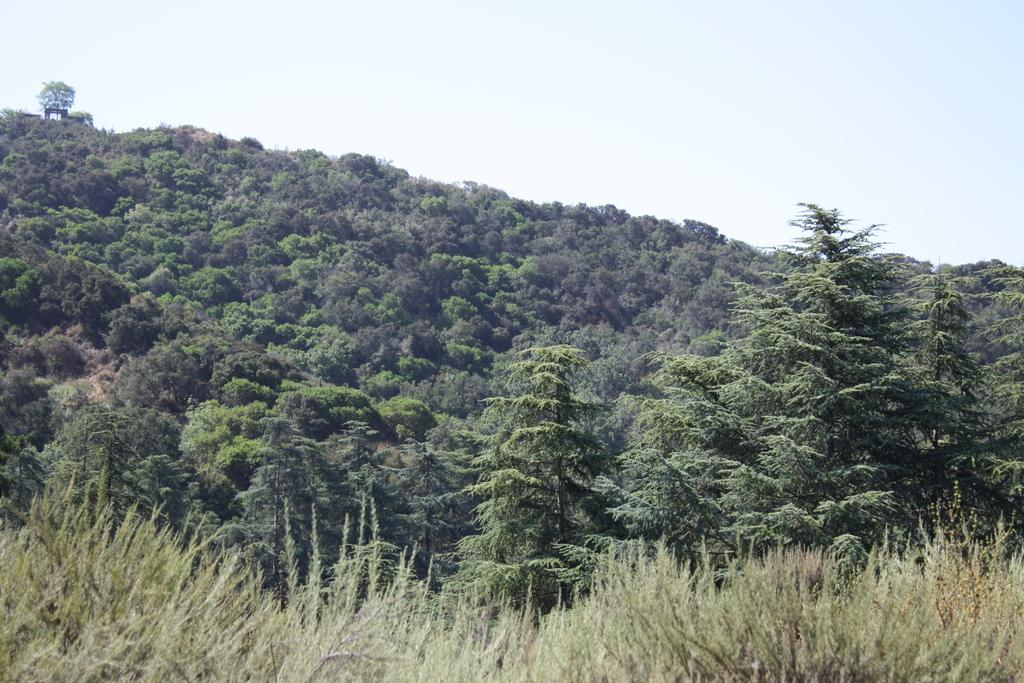What can be seen in the middle of the image? There are trees in the middle of the image. What is visible at the top of the image? The sky is visible at the top of the image. How many ducks are sleeping on the rock in the image? There are no ducks or rocks present in the image; it only features trees and the sky. 